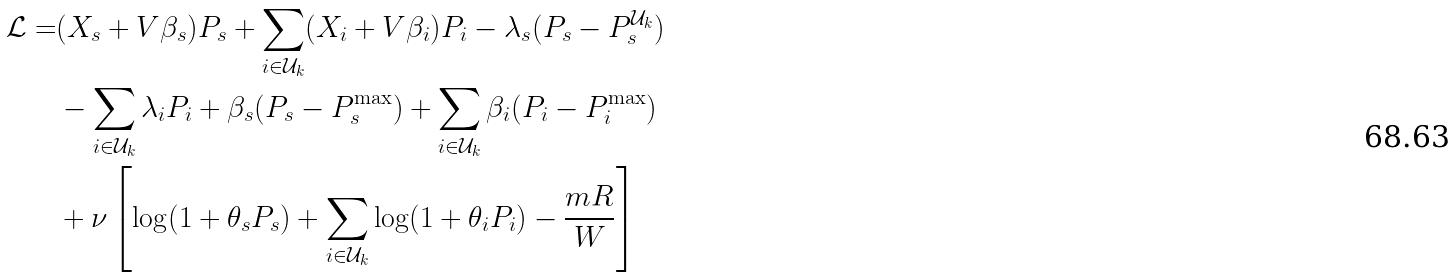Convert formula to latex. <formula><loc_0><loc_0><loc_500><loc_500>\mathcal { L } = & ( X _ { s } + V \beta _ { s } ) P _ { s } + \sum _ { i \in \mathcal { U } _ { k } } ( X _ { i } + V \beta _ { i } ) P _ { i } - \lambda _ { s } ( P _ { s } - P _ { s } ^ { \mathcal { U } _ { k } } ) \\ & - \sum _ { i \in \mathcal { U } _ { k } } \lambda _ { i } P _ { i } + \beta _ { s } ( P _ { s } - P _ { s } ^ { \max } ) + \sum _ { i \in \mathcal { U } _ { k } } \beta _ { i } ( P _ { i } - P _ { i } ^ { \max } ) \\ & + \nu \left [ \log ( 1 + { \theta _ { s } P _ { s } } ) + \sum _ { i \in \mathcal { U } _ { k } } \log ( 1 + \theta _ { i } P _ { i } ) - \frac { m R } { W } \right ]</formula> 